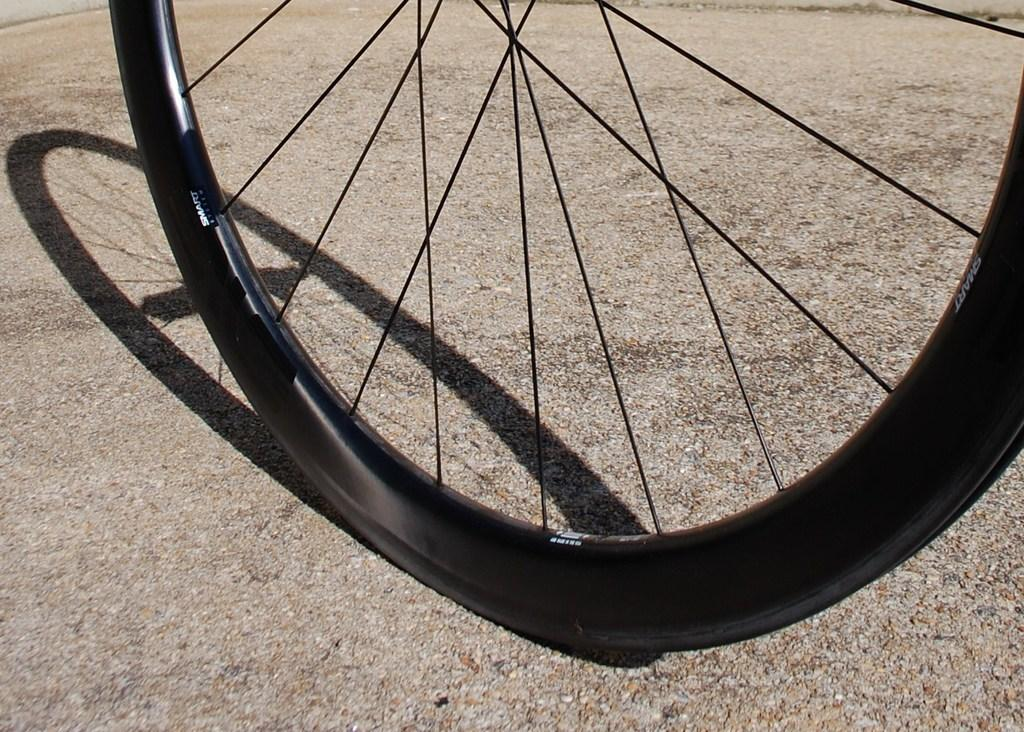What object is the main focus of the image? The main focus of the image is a wheel. What color is the wheel? The wheel is black in color. Where is the wheel located in the image? The wheel is on a surface. How many pizzas are being delivered in the image? There are no pizzas or delivery mentioned in the image; it only features a black wheel on a surface. 